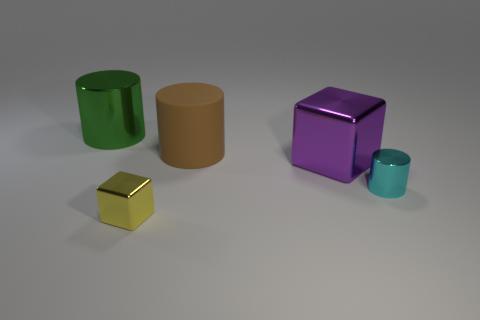Are the green cylinder and the big brown cylinder made of the same material?
Your answer should be compact. No. There is a cyan object that is the same shape as the brown object; what size is it?
Offer a terse response. Small. The tiny thing that is right of the tiny yellow metal cube has what shape?
Make the answer very short. Cylinder. Are the block that is behind the tiny metallic cylinder and the cylinder that is on the right side of the purple metallic cube made of the same material?
Your answer should be compact. Yes. What is the shape of the purple object?
Your response must be concise. Cube. Are there the same number of large purple things behind the brown rubber object and tiny green metallic things?
Offer a very short reply. Yes. Are there any red objects that have the same material as the cyan cylinder?
Ensure brevity in your answer.  No. There is a big metal object that is on the left side of the large matte cylinder; does it have the same shape as the tiny metallic thing that is right of the brown rubber object?
Make the answer very short. Yes. Are any big spheres visible?
Your response must be concise. No. What is the color of the cube that is the same size as the cyan cylinder?
Provide a succinct answer. Yellow. 